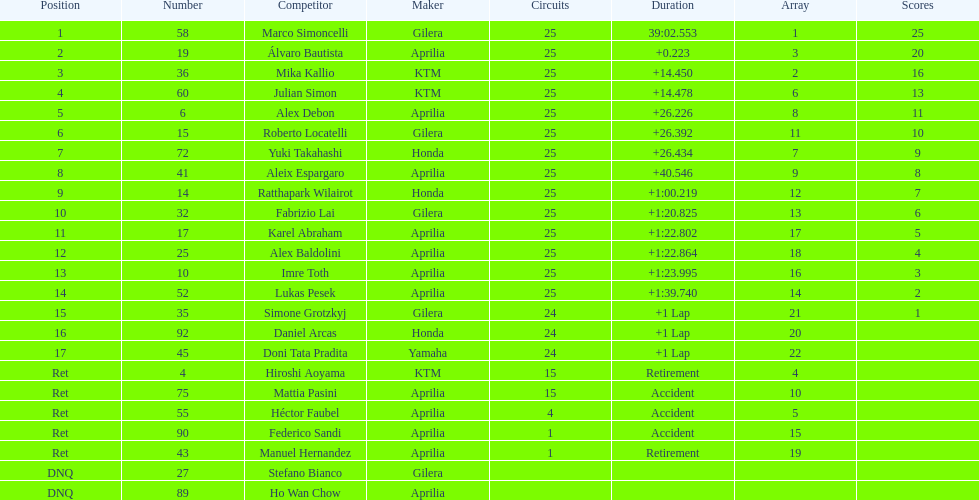Who perfomed the most number of laps, marco simoncelli or hiroshi aoyama? Marco Simoncelli. 